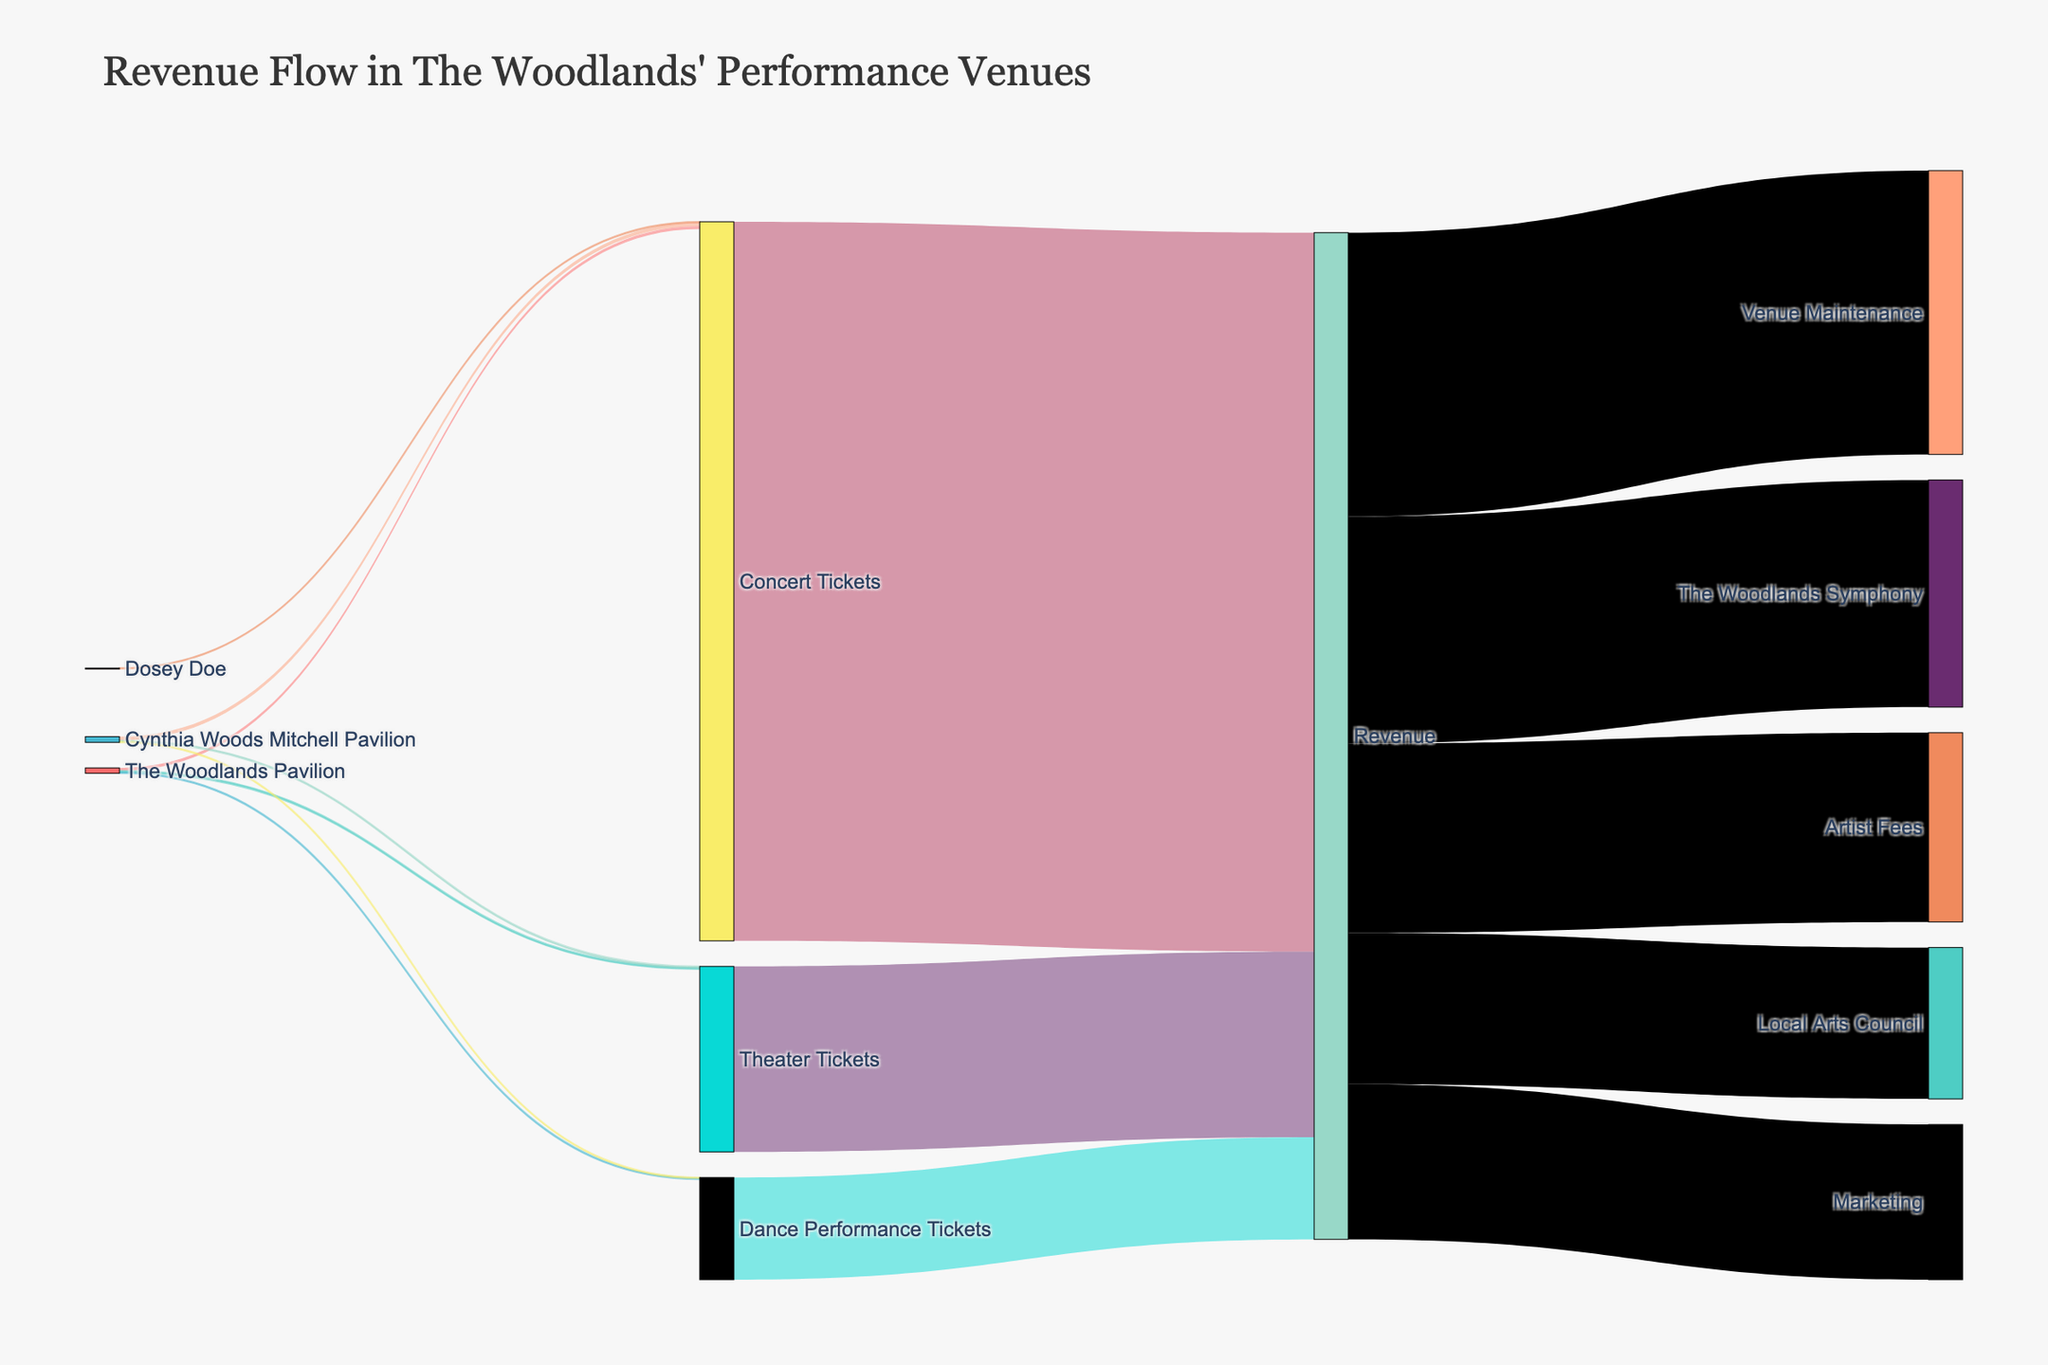what is the title of the figure? The title is usually located at the top of the figure. The title of this Sankey Diagram is "Revenue Flow in The Woodlands' Performance Venues".
Answer: Revenue Flow in The Woodlands' Performance Venues How many performance venues are shown in the diagram? Identify the different sources representing performance venues in the data. There are three: The Woodlands Pavilion, Cynthia Woods Mitchell Pavilion, and Dosey Doe.
Answer: 3 What is the total revenue generated from Concert Tickets? Find the flow from "Concert Tickets" to "Revenue" and look at the value associated with it. The value is 3,800,000.
Answer: 3,800,000 Which performance genre contributes most to revenue? Compare the values flowing into "Revenue" from "Concert Tickets," "Theater Tickets," and "Dance Performance Tickets." The highest value is from "Concert Tickets" with 3,800,000.
Answer: Concert Tickets How many different revenue destinations are there? Look at the targets originating from "Revenue." The unique destinations are The Woodlands Symphony, Local Arts Council, Venue Maintenance, Marketing, and Artist Fees. Count the number of unique targets.
Answer: 5 What percentage of the total revenue is allocated to Marketing? First, sum up all revenues flowing from "Revenue": 1,200,000 (The Woodlands Symphony) + 800,000 (Local Arts Council) + 1,500,000 (Venue Maintenance) + 820,000 (Marketing) + 1,000,000 (Artist Fees) = 5,320,000. Then calculate the percentage: (820,000 / 5,320,000) * 100 ≈ 15.41%
Answer: 15.41% Which venue sold the most Theater Tickets? Compare the values for "Theater Tickets" coming from different sources. Cynthia Woods Mitchell Pavilion has a value of 6,000, and The Woodlands Pavilion has a value of 8,000. The higher value is The Woodlands Pavilion.
Answer: The Woodlands Pavilion How does the number of Dance Performance Tickets sold at Cynthia Woods Mitchell Pavilion compare to The Woodlands Pavilion? Compare the values of Dance Performance Tickets between the two venues. The Cynthia Woods Mitchell Pavilion sold 4,000, while The Woodlands Pavilion sold 5,000.
Answer: The Woodlands Pavilion sold more What is the sum of revenues allocated to The Woodlands Symphony and Artists Fees? Add the values of the revenue flows to The Woodlands Symphony (1,200,000) and Artist Fees (1,000,000). The sum is 1,200,000 + 1,000,000 = 2,200,000.
Answer: 2,200,000 